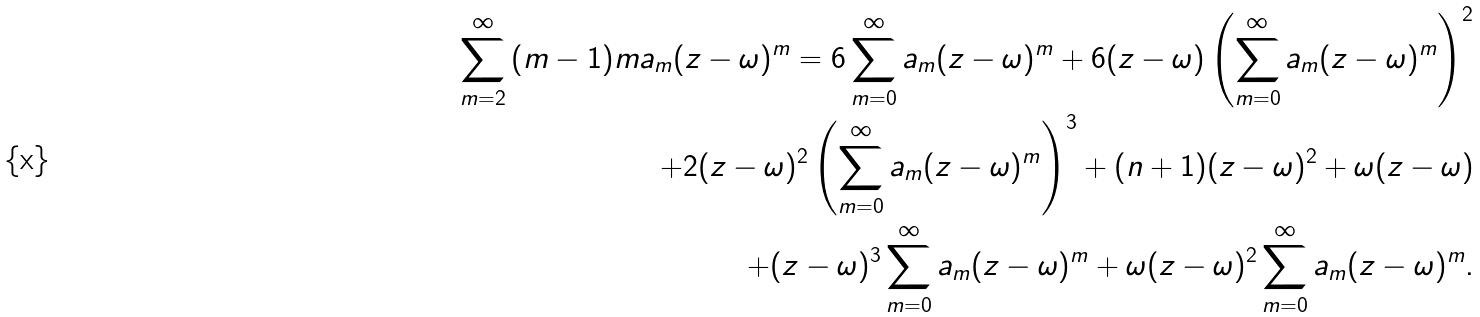<formula> <loc_0><loc_0><loc_500><loc_500>\sum _ { m = 2 } ^ { \infty } { ( m - 1 ) m a _ { m } ( z - \omega ) ^ { m } } = 6 \sum _ { m = 0 } ^ { \infty } { a _ { m } ( z - \omega ) ^ { m } } + 6 ( z - \omega ) \left ( \sum _ { m = 0 } ^ { \infty } { a _ { m } ( z - \omega ) ^ { m } } \right ) ^ { 2 } \\ + 2 ( z - \omega ) ^ { 2 } \left ( \sum _ { m = 0 } ^ { \infty } { a _ { m } ( z - \omega ) ^ { m } } \right ) ^ { 3 } + ( n + 1 ) ( z - \omega ) ^ { 2 } + \omega ( z - \omega ) \\ + ( z - \omega ) ^ { 3 } \sum _ { m = 0 } ^ { \infty } { a _ { m } ( z - \omega ) ^ { m } } + \omega ( z - \omega ) ^ { 2 } \sum _ { m = 0 } ^ { \infty } { a _ { m } ( z - \omega ) ^ { m } } .</formula> 